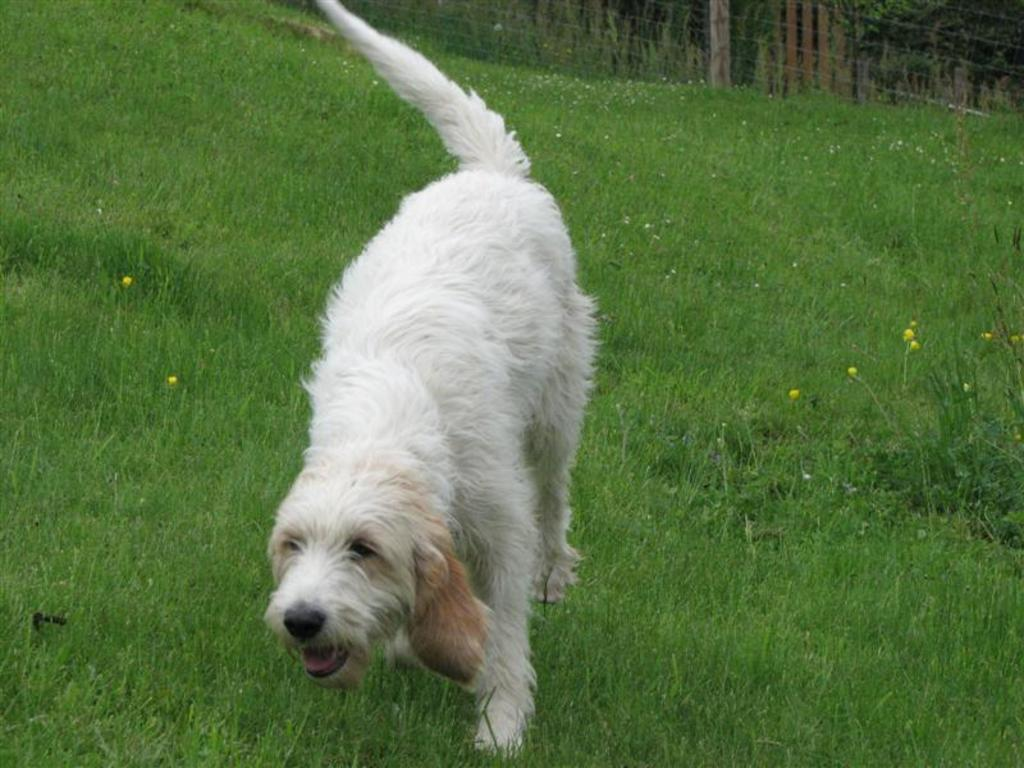What type of animal is present in the image? There is a dog in the image. Where is the dog located? The dog is in a garden. What is the color of the dog? The dog is white in color. What can be seen behind the garden? There is fencing behind the garden. What type of brass instrument is the dog playing in the image? There is no brass instrument present in the image; it features a dog in a garden. 